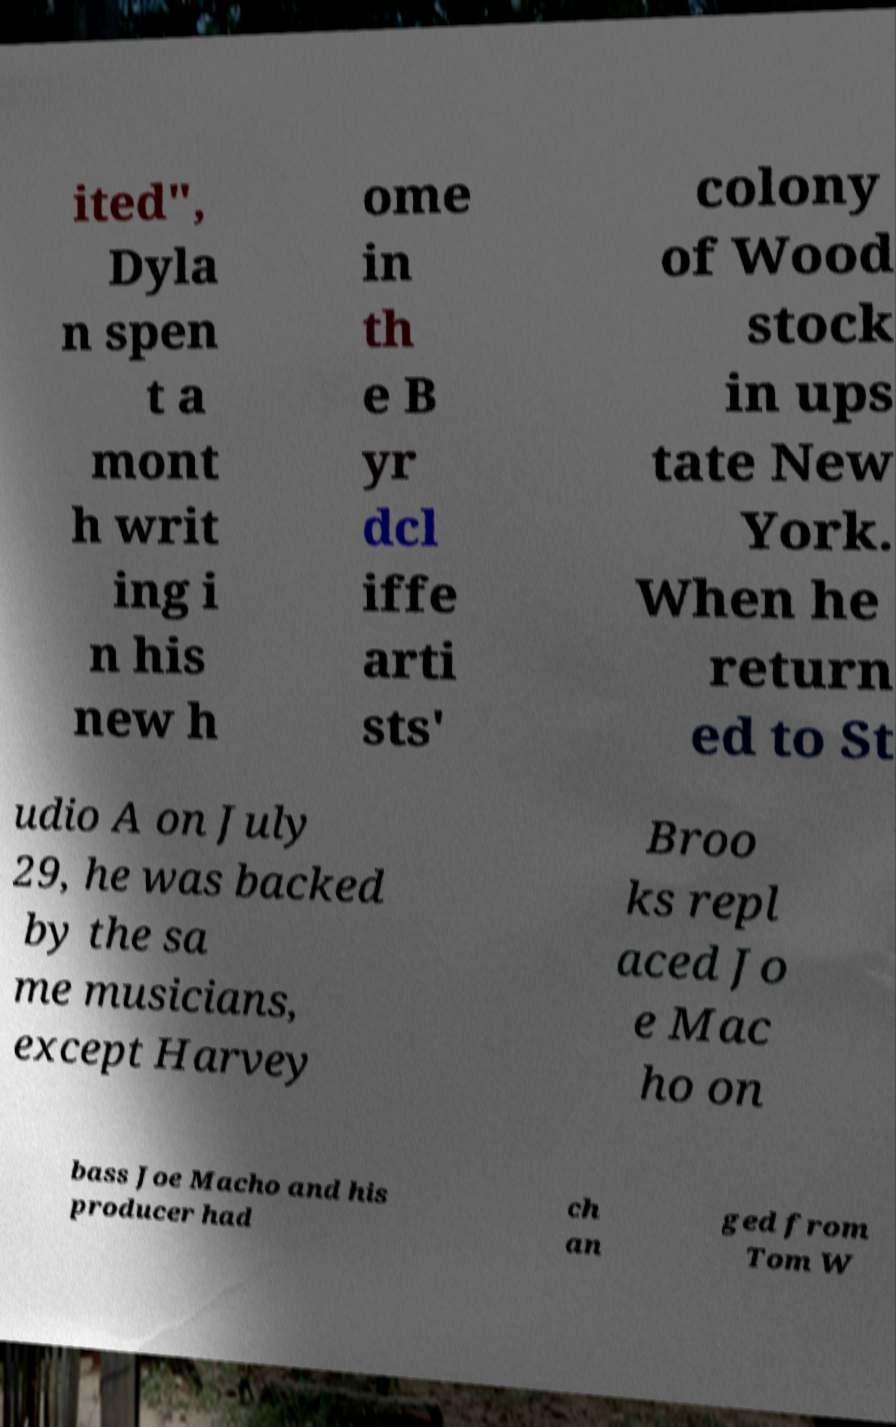Please read and relay the text visible in this image. What does it say? ited", Dyla n spen t a mont h writ ing i n his new h ome in th e B yr dcl iffe arti sts' colony of Wood stock in ups tate New York. When he return ed to St udio A on July 29, he was backed by the sa me musicians, except Harvey Broo ks repl aced Jo e Mac ho on bass Joe Macho and his producer had ch an ged from Tom W 